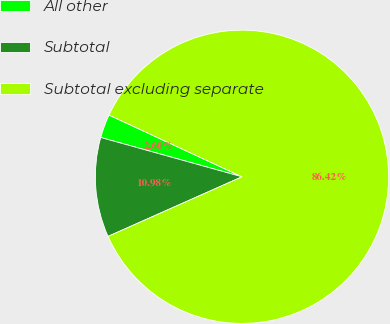Convert chart to OTSL. <chart><loc_0><loc_0><loc_500><loc_500><pie_chart><fcel>All other<fcel>Subtotal<fcel>Subtotal excluding separate<nl><fcel>2.6%<fcel>10.98%<fcel>86.41%<nl></chart> 